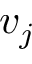<formula> <loc_0><loc_0><loc_500><loc_500>v _ { j }</formula> 